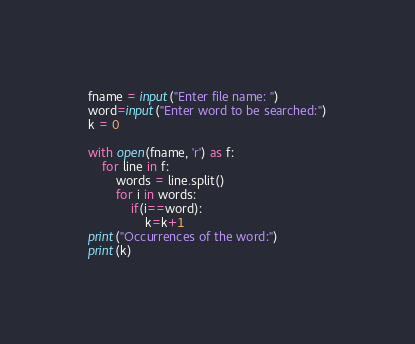Convert code to text. <code><loc_0><loc_0><loc_500><loc_500><_Python_>fname = input("Enter file name: ")
word=input("Enter word to be searched:")
k = 0
 
with open(fname, 'r') as f:
    for line in f:
        words = line.split()
        for i in words:
            if(i==word):
                k=k+1
print("Occurrences of the word:")
print(k)
</code> 